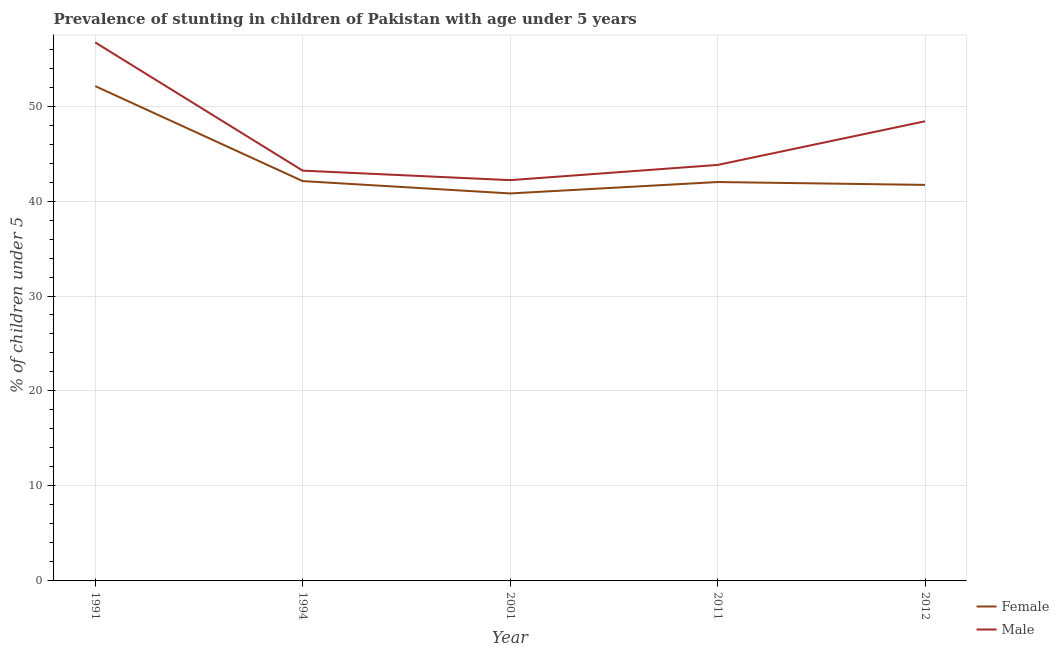Does the line corresponding to percentage of stunted female children intersect with the line corresponding to percentage of stunted male children?
Ensure brevity in your answer.  No. What is the percentage of stunted male children in 2012?
Provide a short and direct response. 48.4. Across all years, what is the maximum percentage of stunted female children?
Your answer should be compact. 52.1. Across all years, what is the minimum percentage of stunted female children?
Offer a terse response. 40.8. In which year was the percentage of stunted female children maximum?
Keep it short and to the point. 1991. What is the total percentage of stunted male children in the graph?
Keep it short and to the point. 234.3. What is the difference between the percentage of stunted female children in 2001 and that in 2012?
Offer a very short reply. -0.9. What is the difference between the percentage of stunted male children in 2012 and the percentage of stunted female children in 2001?
Provide a short and direct response. 7.6. What is the average percentage of stunted female children per year?
Make the answer very short. 43.74. In the year 1994, what is the difference between the percentage of stunted male children and percentage of stunted female children?
Keep it short and to the point. 1.1. In how many years, is the percentage of stunted female children greater than 2 %?
Provide a short and direct response. 5. What is the ratio of the percentage of stunted female children in 1994 to that in 2011?
Make the answer very short. 1. Is the percentage of stunted female children in 1994 less than that in 2011?
Provide a short and direct response. No. Is the difference between the percentage of stunted female children in 2001 and 2012 greater than the difference between the percentage of stunted male children in 2001 and 2012?
Ensure brevity in your answer.  Yes. What is the difference between the highest and the lowest percentage of stunted male children?
Make the answer very short. 14.5. In how many years, is the percentage of stunted female children greater than the average percentage of stunted female children taken over all years?
Your answer should be compact. 1. Does the percentage of stunted female children monotonically increase over the years?
Provide a short and direct response. No. Is the percentage of stunted male children strictly greater than the percentage of stunted female children over the years?
Offer a terse response. Yes. How many years are there in the graph?
Offer a very short reply. 5. Does the graph contain grids?
Make the answer very short. Yes. How many legend labels are there?
Offer a terse response. 2. What is the title of the graph?
Keep it short and to the point. Prevalence of stunting in children of Pakistan with age under 5 years. What is the label or title of the Y-axis?
Keep it short and to the point.  % of children under 5. What is the  % of children under 5 in Female in 1991?
Your response must be concise. 52.1. What is the  % of children under 5 of Male in 1991?
Provide a short and direct response. 56.7. What is the  % of children under 5 in Female in 1994?
Offer a terse response. 42.1. What is the  % of children under 5 of Male in 1994?
Provide a short and direct response. 43.2. What is the  % of children under 5 in Female in 2001?
Offer a very short reply. 40.8. What is the  % of children under 5 in Male in 2001?
Give a very brief answer. 42.2. What is the  % of children under 5 in Female in 2011?
Provide a short and direct response. 42. What is the  % of children under 5 in Male in 2011?
Your response must be concise. 43.8. What is the  % of children under 5 of Female in 2012?
Ensure brevity in your answer.  41.7. What is the  % of children under 5 in Male in 2012?
Make the answer very short. 48.4. Across all years, what is the maximum  % of children under 5 of Female?
Offer a very short reply. 52.1. Across all years, what is the maximum  % of children under 5 of Male?
Offer a terse response. 56.7. Across all years, what is the minimum  % of children under 5 of Female?
Your answer should be compact. 40.8. Across all years, what is the minimum  % of children under 5 in Male?
Your answer should be compact. 42.2. What is the total  % of children under 5 of Female in the graph?
Make the answer very short. 218.7. What is the total  % of children under 5 of Male in the graph?
Keep it short and to the point. 234.3. What is the difference between the  % of children under 5 of Female in 1991 and that in 1994?
Keep it short and to the point. 10. What is the difference between the  % of children under 5 in Male in 1991 and that in 1994?
Offer a very short reply. 13.5. What is the difference between the  % of children under 5 of Female in 1991 and that in 2001?
Provide a short and direct response. 11.3. What is the difference between the  % of children under 5 of Male in 1991 and that in 2001?
Keep it short and to the point. 14.5. What is the difference between the  % of children under 5 in Female in 1991 and that in 2011?
Provide a succinct answer. 10.1. What is the difference between the  % of children under 5 of Male in 1991 and that in 2012?
Your answer should be compact. 8.3. What is the difference between the  % of children under 5 in Male in 1994 and that in 2012?
Make the answer very short. -5.2. What is the difference between the  % of children under 5 in Male in 2001 and that in 2011?
Keep it short and to the point. -1.6. What is the difference between the  % of children under 5 of Female in 2001 and that in 2012?
Your answer should be compact. -0.9. What is the difference between the  % of children under 5 of Male in 2001 and that in 2012?
Make the answer very short. -6.2. What is the difference between the  % of children under 5 of Female in 1991 and the  % of children under 5 of Male in 1994?
Offer a very short reply. 8.9. What is the difference between the  % of children under 5 of Female in 1991 and the  % of children under 5 of Male in 2001?
Offer a very short reply. 9.9. What is the difference between the  % of children under 5 of Female in 1991 and the  % of children under 5 of Male in 2011?
Provide a succinct answer. 8.3. What is the difference between the  % of children under 5 in Female in 1994 and the  % of children under 5 in Male in 2012?
Provide a succinct answer. -6.3. What is the difference between the  % of children under 5 of Female in 2001 and the  % of children under 5 of Male in 2011?
Offer a terse response. -3. What is the difference between the  % of children under 5 in Female in 2001 and the  % of children under 5 in Male in 2012?
Your answer should be compact. -7.6. What is the average  % of children under 5 of Female per year?
Make the answer very short. 43.74. What is the average  % of children under 5 in Male per year?
Offer a very short reply. 46.86. In the year 1991, what is the difference between the  % of children under 5 in Female and  % of children under 5 in Male?
Your answer should be compact. -4.6. In the year 1994, what is the difference between the  % of children under 5 in Female and  % of children under 5 in Male?
Make the answer very short. -1.1. In the year 2001, what is the difference between the  % of children under 5 of Female and  % of children under 5 of Male?
Your answer should be compact. -1.4. In the year 2012, what is the difference between the  % of children under 5 of Female and  % of children under 5 of Male?
Offer a terse response. -6.7. What is the ratio of the  % of children under 5 of Female in 1991 to that in 1994?
Your answer should be compact. 1.24. What is the ratio of the  % of children under 5 in Male in 1991 to that in 1994?
Your answer should be very brief. 1.31. What is the ratio of the  % of children under 5 in Female in 1991 to that in 2001?
Keep it short and to the point. 1.28. What is the ratio of the  % of children under 5 of Male in 1991 to that in 2001?
Ensure brevity in your answer.  1.34. What is the ratio of the  % of children under 5 in Female in 1991 to that in 2011?
Provide a succinct answer. 1.24. What is the ratio of the  % of children under 5 in Male in 1991 to that in 2011?
Your answer should be compact. 1.29. What is the ratio of the  % of children under 5 of Female in 1991 to that in 2012?
Keep it short and to the point. 1.25. What is the ratio of the  % of children under 5 of Male in 1991 to that in 2012?
Give a very brief answer. 1.17. What is the ratio of the  % of children under 5 of Female in 1994 to that in 2001?
Offer a very short reply. 1.03. What is the ratio of the  % of children under 5 of Male in 1994 to that in 2001?
Your response must be concise. 1.02. What is the ratio of the  % of children under 5 of Male in 1994 to that in 2011?
Provide a short and direct response. 0.99. What is the ratio of the  % of children under 5 in Female in 1994 to that in 2012?
Provide a short and direct response. 1.01. What is the ratio of the  % of children under 5 in Male in 1994 to that in 2012?
Your answer should be compact. 0.89. What is the ratio of the  % of children under 5 of Female in 2001 to that in 2011?
Your answer should be very brief. 0.97. What is the ratio of the  % of children under 5 in Male in 2001 to that in 2011?
Your answer should be very brief. 0.96. What is the ratio of the  % of children under 5 in Female in 2001 to that in 2012?
Offer a very short reply. 0.98. What is the ratio of the  % of children under 5 in Male in 2001 to that in 2012?
Give a very brief answer. 0.87. What is the ratio of the  % of children under 5 in Female in 2011 to that in 2012?
Provide a short and direct response. 1.01. What is the ratio of the  % of children under 5 of Male in 2011 to that in 2012?
Your answer should be very brief. 0.91. What is the difference between the highest and the second highest  % of children under 5 of Female?
Ensure brevity in your answer.  10. What is the difference between the highest and the second highest  % of children under 5 of Male?
Provide a short and direct response. 8.3. 